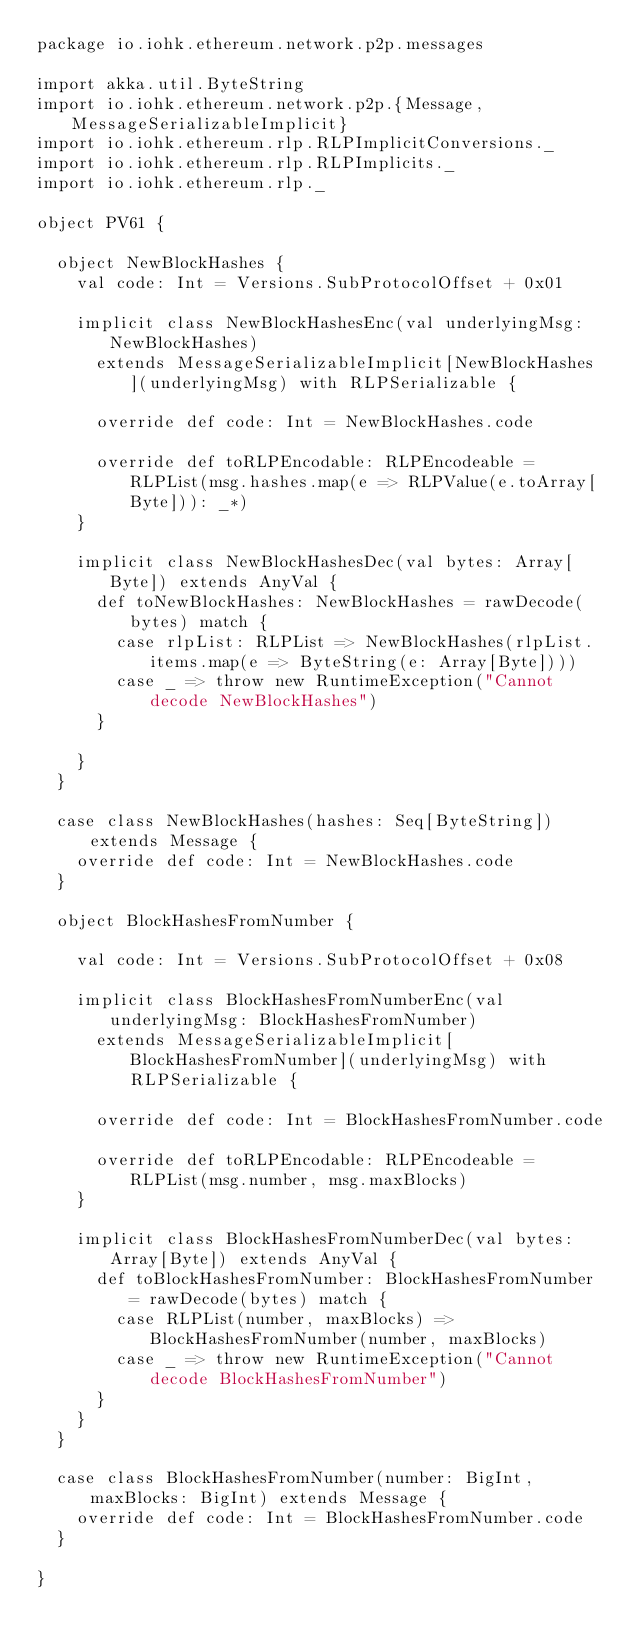<code> <loc_0><loc_0><loc_500><loc_500><_Scala_>package io.iohk.ethereum.network.p2p.messages

import akka.util.ByteString
import io.iohk.ethereum.network.p2p.{Message, MessageSerializableImplicit}
import io.iohk.ethereum.rlp.RLPImplicitConversions._
import io.iohk.ethereum.rlp.RLPImplicits._
import io.iohk.ethereum.rlp._

object PV61 {

  object NewBlockHashes {
    val code: Int = Versions.SubProtocolOffset + 0x01

    implicit class NewBlockHashesEnc(val underlyingMsg: NewBlockHashes)
      extends MessageSerializableImplicit[NewBlockHashes](underlyingMsg) with RLPSerializable {

      override def code: Int = NewBlockHashes.code

      override def toRLPEncodable: RLPEncodeable = RLPList(msg.hashes.map(e => RLPValue(e.toArray[Byte])): _*)
    }

    implicit class NewBlockHashesDec(val bytes: Array[Byte]) extends AnyVal {
      def toNewBlockHashes: NewBlockHashes = rawDecode(bytes) match {
        case rlpList: RLPList => NewBlockHashes(rlpList.items.map(e => ByteString(e: Array[Byte])))
        case _ => throw new RuntimeException("Cannot decode NewBlockHashes")
      }

    }
  }

  case class NewBlockHashes(hashes: Seq[ByteString]) extends Message {
    override def code: Int = NewBlockHashes.code
  }

  object BlockHashesFromNumber {

    val code: Int = Versions.SubProtocolOffset + 0x08

    implicit class BlockHashesFromNumberEnc(val underlyingMsg: BlockHashesFromNumber)
      extends MessageSerializableImplicit[BlockHashesFromNumber](underlyingMsg) with RLPSerializable {

      override def code: Int = BlockHashesFromNumber.code

      override def toRLPEncodable: RLPEncodeable = RLPList(msg.number, msg.maxBlocks)
    }

    implicit class BlockHashesFromNumberDec(val bytes: Array[Byte]) extends AnyVal {
      def toBlockHashesFromNumber: BlockHashesFromNumber = rawDecode(bytes) match {
        case RLPList(number, maxBlocks) => BlockHashesFromNumber(number, maxBlocks)
        case _ => throw new RuntimeException("Cannot decode BlockHashesFromNumber")
      }
    }
  }

  case class BlockHashesFromNumber(number: BigInt, maxBlocks: BigInt) extends Message {
    override def code: Int = BlockHashesFromNumber.code
  }

}
</code> 